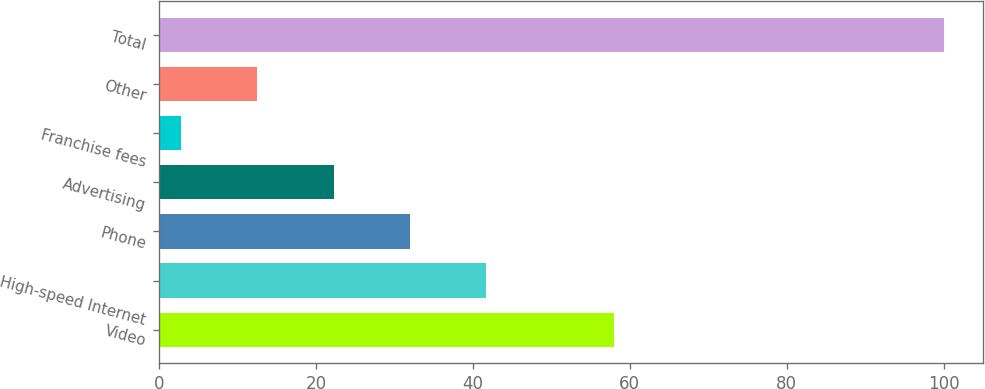Convert chart to OTSL. <chart><loc_0><loc_0><loc_500><loc_500><bar_chart><fcel>Video<fcel>High-speed Internet<fcel>Phone<fcel>Advertising<fcel>Franchise fees<fcel>Other<fcel>Total<nl><fcel>58<fcel>41.68<fcel>31.96<fcel>22.24<fcel>2.8<fcel>12.52<fcel>100<nl></chart> 